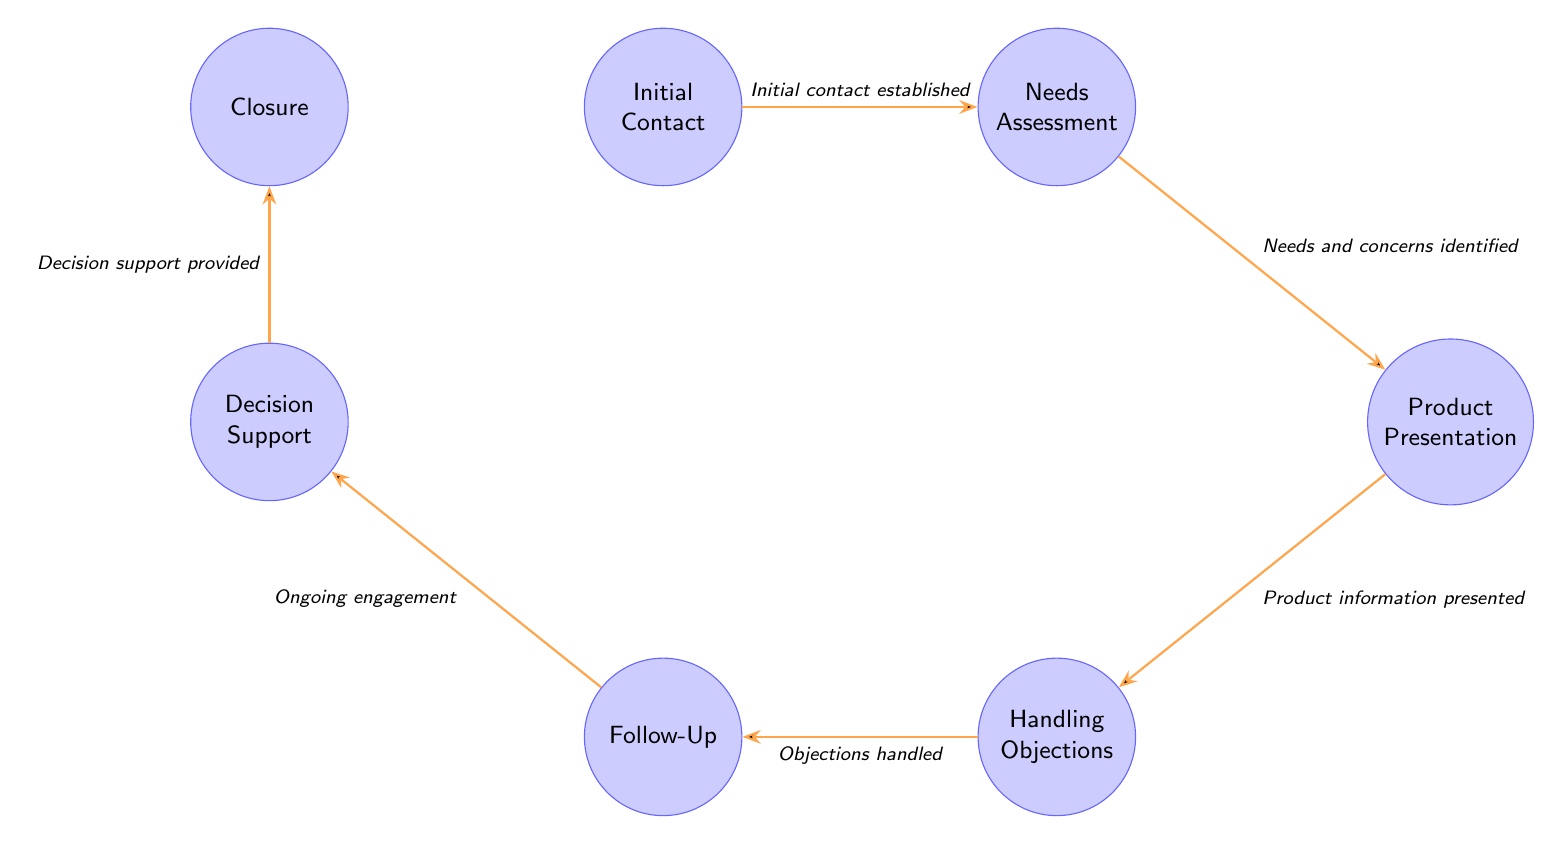What is the first node in the cycle? The first node in the cycle is "Initial Contact," as it is the starting point of the engagement process depicted in the diagram.
Answer: Initial Contact How many nodes are there in total? The diagram shows a total of seven nodes, each representing a distinct step in the Physician Engagement Cycle.
Answer: 7 What is the condition for transitioning from "Needs Assessment" to "Product Presentation"? The transition from "Needs Assessment" to "Product Presentation" occurs when "Needs and concerns identified," indicating that the physician's specific requirements have been understood.
Answer: Needs and concerns identified What node follows "Follow-Up"? After "Follow-Up," the next node in the sequence is "Decision Support," which focuses on assisting physicians in making informed choices regarding the pharmaceutical products.
Answer: Decision Support Which two nodes are directly connected without any intermediary node? The nodes "Follow-Up" and "Decision Support" are directly connected without any intermediary node in between, signifying a seamless transition in the engagement process.
Answer: Follow-Up and Decision Support How many transitions are there in the diagram? There are six transitions within the diagram, which represent the conditions that facilitate movement from one stage to the next in the engagement cycle.
Answer: 6 What is the condition for the final transition leading to "Closure"? The final transition leading to "Closure" occurs when "Decision support provided," indicating that adequate support has been given to aid in the physician's decision-making process.
Answer: Decision support provided Which node describes the action of addressing concerns? The node "Handling Objections" describes the action of addressing the concerns or objections that physicians may have regarding the pharmaceutical products.
Answer: Handling Objections What node comes before "Decision Support"? The node that comes directly before "Decision Support" is "Follow-Up," which underscores the importance of maintaining ongoing engagement with the physician.
Answer: Follow-Up 